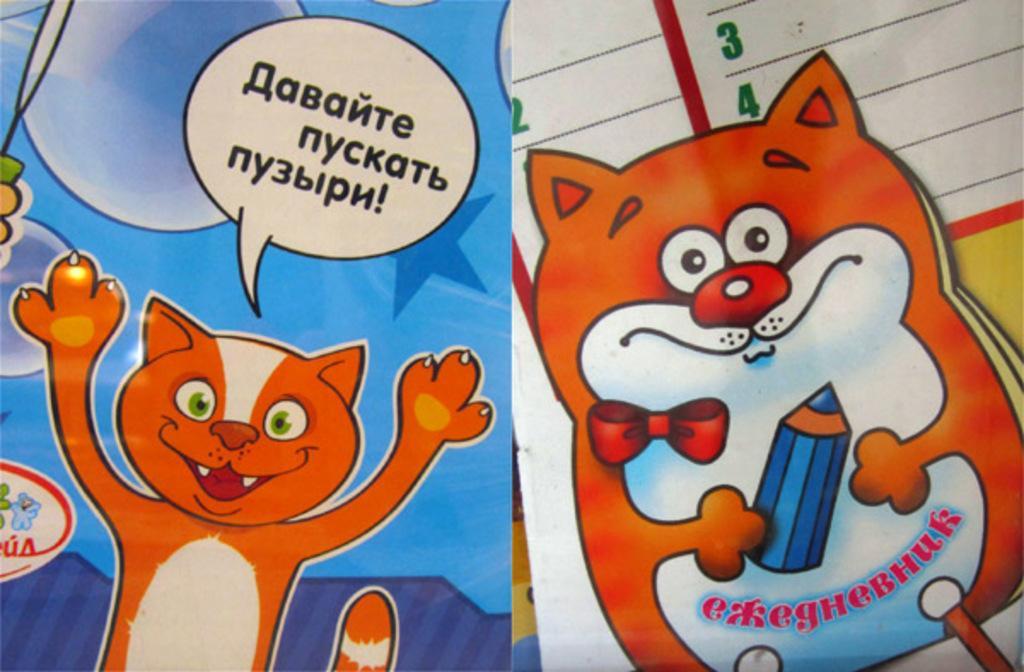Can you describe this image briefly? In this picture we can see animated images and some text. 